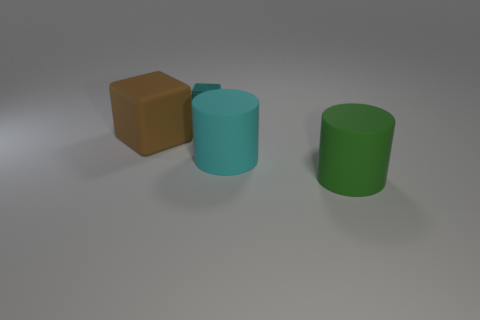There is a brown object that is to the left of the cyan object that is behind the big object that is to the left of the tiny metal thing; how big is it?
Your answer should be compact. Large. What is the size of the cyan metal cube?
Make the answer very short. Small. Is there any other thing that has the same material as the tiny cyan thing?
Provide a short and direct response. No. There is a cyan object that is in front of the block that is on the left side of the small cyan metallic thing; are there any large things that are to the left of it?
Provide a succinct answer. Yes. What number of small objects are green balls or cyan matte objects?
Your answer should be compact. 0. Is there any other thing that is the same color as the small block?
Ensure brevity in your answer.  Yes. There is a object that is behind the matte block; does it have the same size as the large cyan matte thing?
Make the answer very short. No. What color is the object that is behind the large rubber object that is left of the block on the right side of the brown block?
Offer a terse response. Cyan. The rubber cube is what color?
Provide a succinct answer. Brown. Is the color of the matte block the same as the small block?
Give a very brief answer. No. 